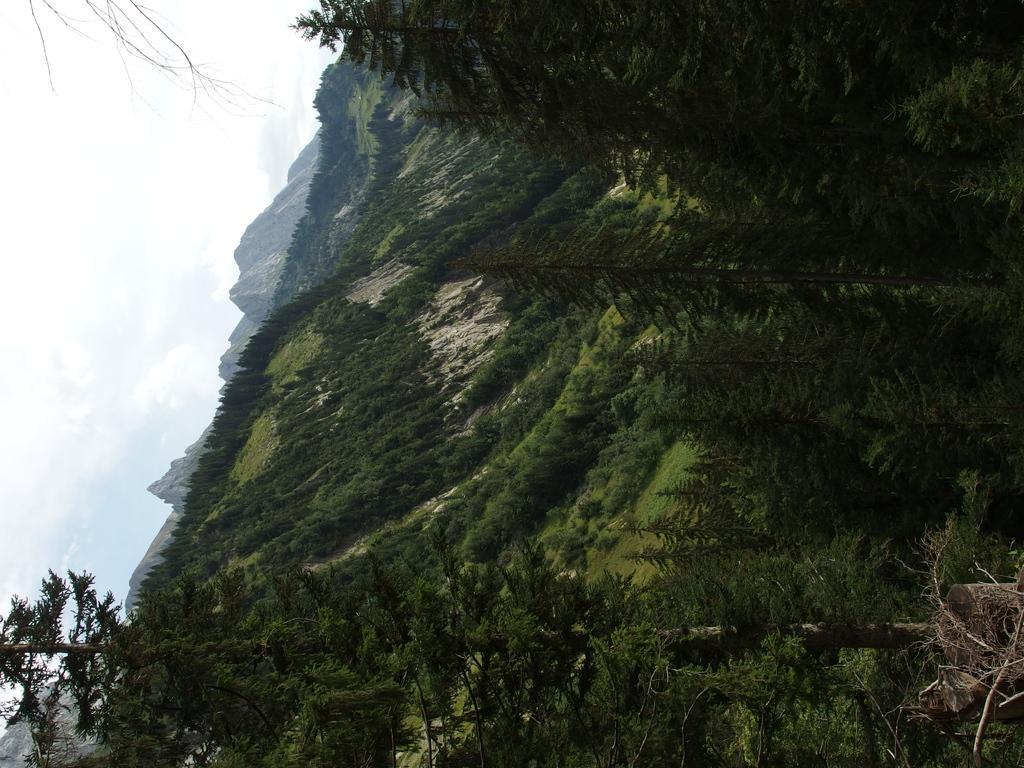How would you summarize this image in a sentence or two? This image consists of mountains which are covered with plants and trees. To the left, there is a tree. And there are clouds in the sky. 